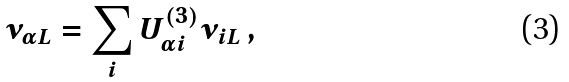Convert formula to latex. <formula><loc_0><loc_0><loc_500><loc_500>\nu _ { \alpha L } = \sum _ { i } U ^ { ( 3 ) } _ { \alpha i } \nu _ { i L } \, ,</formula> 